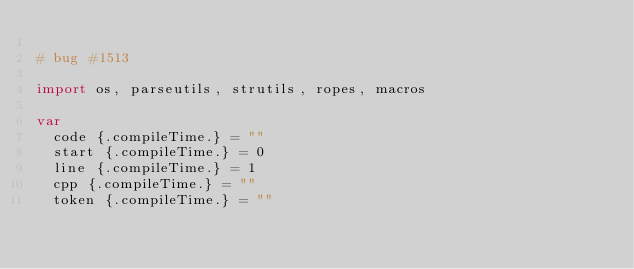<code> <loc_0><loc_0><loc_500><loc_500><_Nim_>
# bug #1513

import os, parseutils, strutils, ropes, macros

var
  code {.compileTime.} = ""
  start {.compileTime.} = 0
  line {.compileTime.} = 1
  cpp {.compileTime.} = ""
  token {.compileTime.} = ""
</code> 